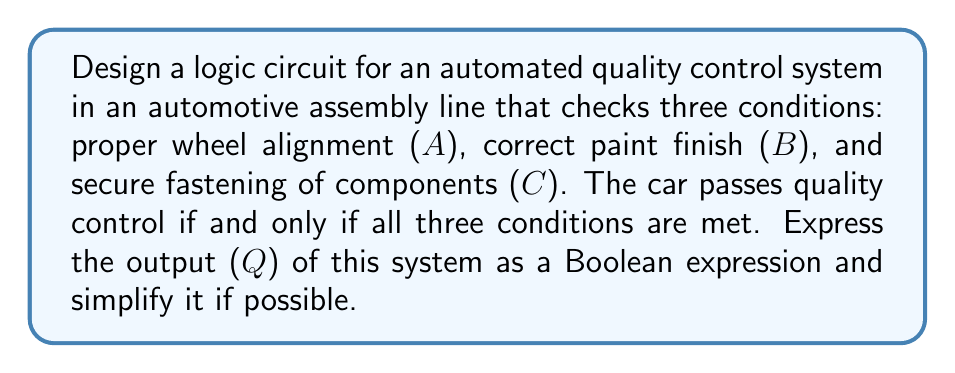Help me with this question. Let's approach this step-by-step:

1) First, we need to define our variables:
   A: Proper wheel alignment
   B: Correct paint finish
   C: Secure fastening of components
   Q: Output (car passes quality control)

2) The car passes quality control if and only if all three conditions are met. This can be expressed as a logical AND operation:

   $Q = A \cdot B \cdot C$

3) In Boolean algebra, this is already in its simplest form. The dot notation ($\cdot$) represents the AND operation.

4) We can also represent this using the intersection symbol:

   $Q = A \cap B \cap C$

5) The logic circuit for this system would be a simple AND gate with three inputs:

   [asy]
   import geometry;

   size(200);

   path andGate = (0,0)--(0,40)--(20,40)..controls (40,40) and (40,0)..(20,0)--cycle;

   draw(andGate);
   draw((0,30)--(0,40));
   draw((0,20)--(0,20));
   draw((0,10)--(0,0));
   draw((40,20)--(60,20));

   label("A", (-10,30), W);
   label("B", (-10,20), W);
   label("C", (-10,10), W);
   label("Q", (65,20), E);

   label("AND", (20,20));
   [/asy]

6) This circuit will output 1 (true) only when all inputs A, B, and C are 1 (true), which aligns with our requirement that the car passes quality control only when all three conditions are met.
Answer: $Q = A \cdot B \cdot C$ 